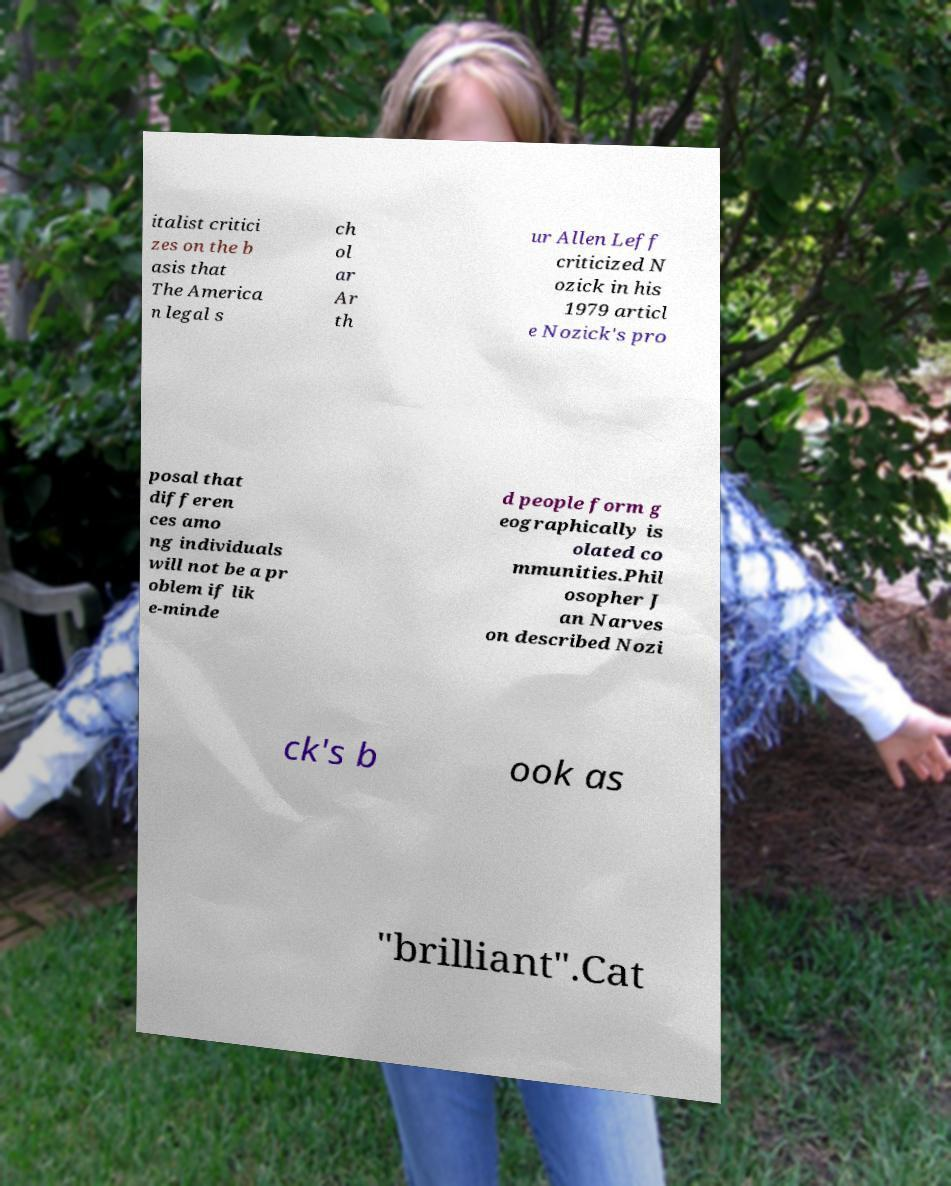Could you assist in decoding the text presented in this image and type it out clearly? italist critici zes on the b asis that The America n legal s ch ol ar Ar th ur Allen Leff criticized N ozick in his 1979 articl e Nozick's pro posal that differen ces amo ng individuals will not be a pr oblem if lik e-minde d people form g eographically is olated co mmunities.Phil osopher J an Narves on described Nozi ck's b ook as "brilliant".Cat 